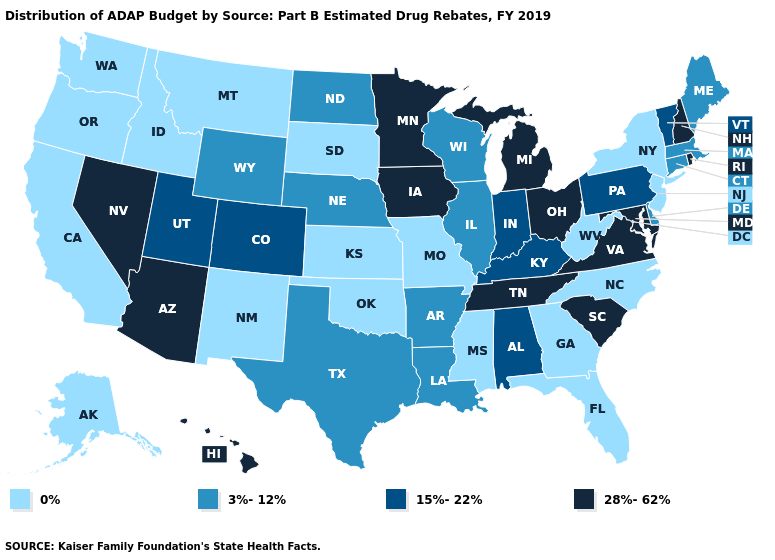What is the value of Indiana?
Write a very short answer. 15%-22%. Name the states that have a value in the range 15%-22%?
Quick response, please. Alabama, Colorado, Indiana, Kentucky, Pennsylvania, Utah, Vermont. Name the states that have a value in the range 3%-12%?
Write a very short answer. Arkansas, Connecticut, Delaware, Illinois, Louisiana, Maine, Massachusetts, Nebraska, North Dakota, Texas, Wisconsin, Wyoming. Does Arizona have a lower value than Massachusetts?
Answer briefly. No. What is the highest value in the USA?
Answer briefly. 28%-62%. Among the states that border Texas , which have the lowest value?
Keep it brief. New Mexico, Oklahoma. Name the states that have a value in the range 0%?
Short answer required. Alaska, California, Florida, Georgia, Idaho, Kansas, Mississippi, Missouri, Montana, New Jersey, New Mexico, New York, North Carolina, Oklahoma, Oregon, South Dakota, Washington, West Virginia. What is the lowest value in states that border Arizona?
Answer briefly. 0%. What is the value of Alabama?
Quick response, please. 15%-22%. What is the lowest value in the USA?
Be succinct. 0%. What is the lowest value in the West?
Answer briefly. 0%. Which states have the highest value in the USA?
Keep it brief. Arizona, Hawaii, Iowa, Maryland, Michigan, Minnesota, Nevada, New Hampshire, Ohio, Rhode Island, South Carolina, Tennessee, Virginia. What is the value of New York?
Concise answer only. 0%. 